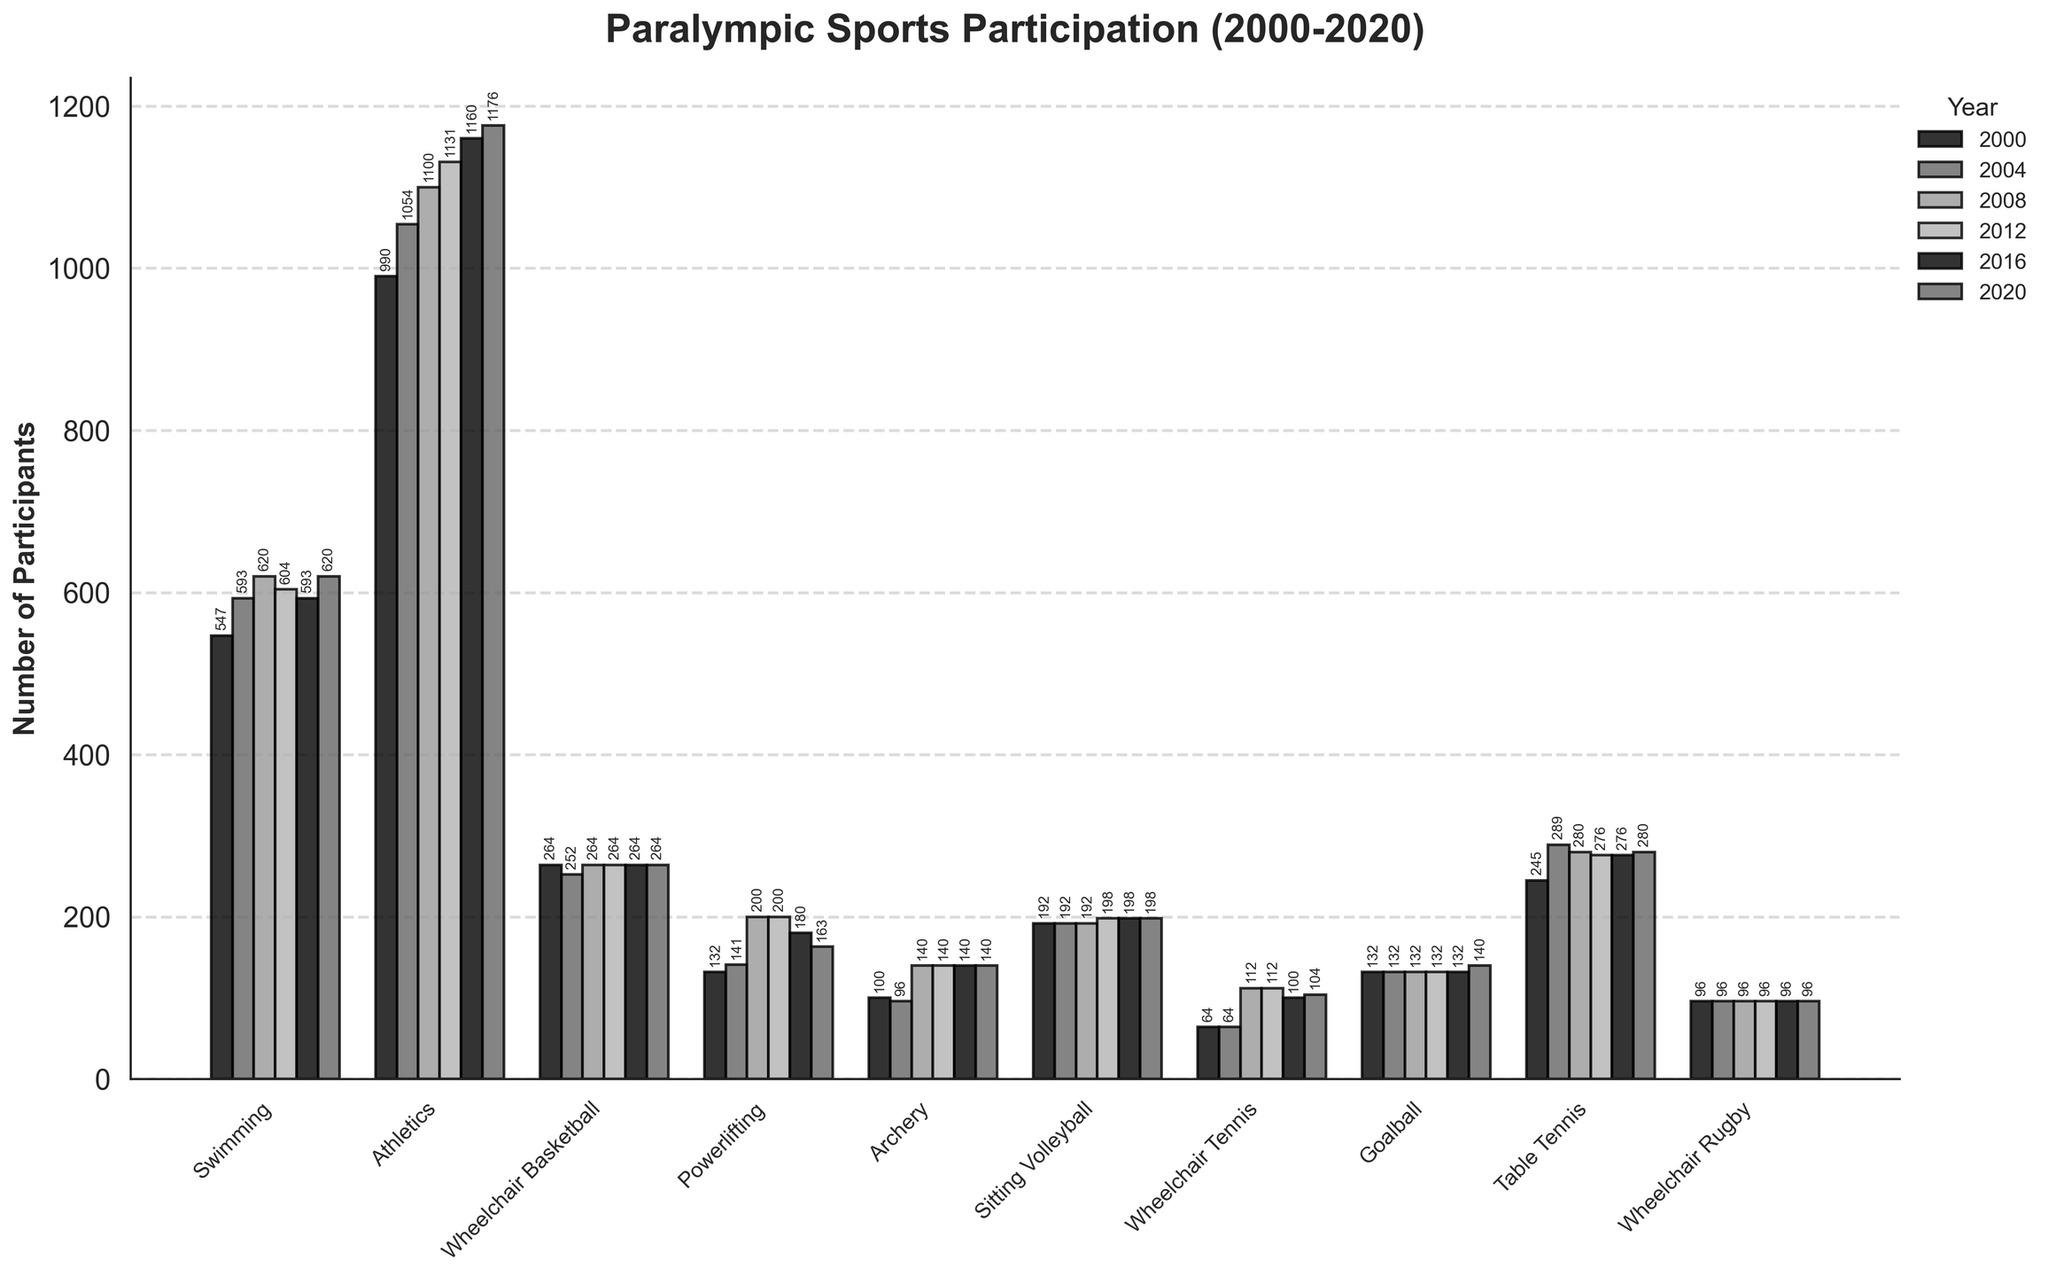Which sport had the highest number of participants in 2020? Look for the tallest bar in the 2020 section of the plot. Athletics has the tallest bar in 2020.
Answer: Athletics How did the number of participants in Sitting Volleyball change from 2000 to 2020? Compare the heights of the bars for Sitting Volleyball in 2000 and 2020. Both years have almost the same bar height.
Answer: Stayed the same Which sport saw the largest increase in participants from 2004 to 2008? Compare the differences in bar heights between 2004 and 2008 for each sport. Powerlifting shows the largest relative increase.
Answer: Powerlifting What is the trend for Goalball participant numbers over the years 2000 to 2020? Observe the height of the bars for Goalball across all years. The bars show slight increase in 2020.
Answer: Slight increase For which sport did the number of participants remain constant across all years? Identify the sport where the height of the bars remains the same in every year column. Wheelchair Rugby has constant-height bars.
Answer: Wheelchair Rugby In which year did Swimming have the highest number of participants? Compare the bar heights for Swimming across all years and identify the tallest one. Both 2008 and 2020 have the highest bar.
Answer: 2008 and 2020 How many total participants were there for Wheelchair Tennis in 2012 and 2016 combined? Sum the heights of the bars for Wheelchair Tennis in 2012 and 2016. Both are 112 and 100, so 112 + 100.
Answer: 212 Which year had the lowest participation in Archery? Find the lowest bar in the Archery section and note the corresponding year. 2004 had the lowest bar height.
Answer: 2004 What is the overall trend for Athletics participants from 2000 to 2020? Observe the sequence of bar heights for Athletics across all years. The bars consistently increase in height over time.
Answer: Increasing Compare the total number of participants in Powerlifting in 2000 and 2020. Sum the values for Powerlifting participants in 2000 and 2020. 132 in 2000 and 163 in 2020.
Answer: Increase by 31 